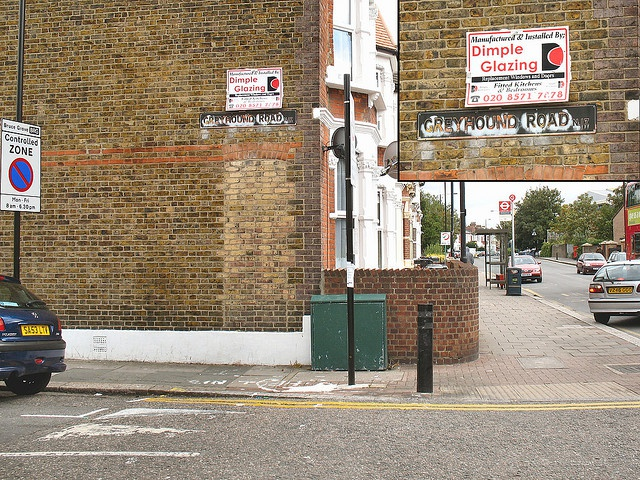Describe the objects in this image and their specific colors. I can see car in olive, black, gray, and darkgreen tones, car in olive, darkgray, black, lightgray, and gray tones, car in olive, lightgray, darkgray, black, and lightpink tones, car in olive, lightgray, gray, darkgray, and black tones, and car in olive, lightgray, darkgray, lightblue, and black tones in this image. 